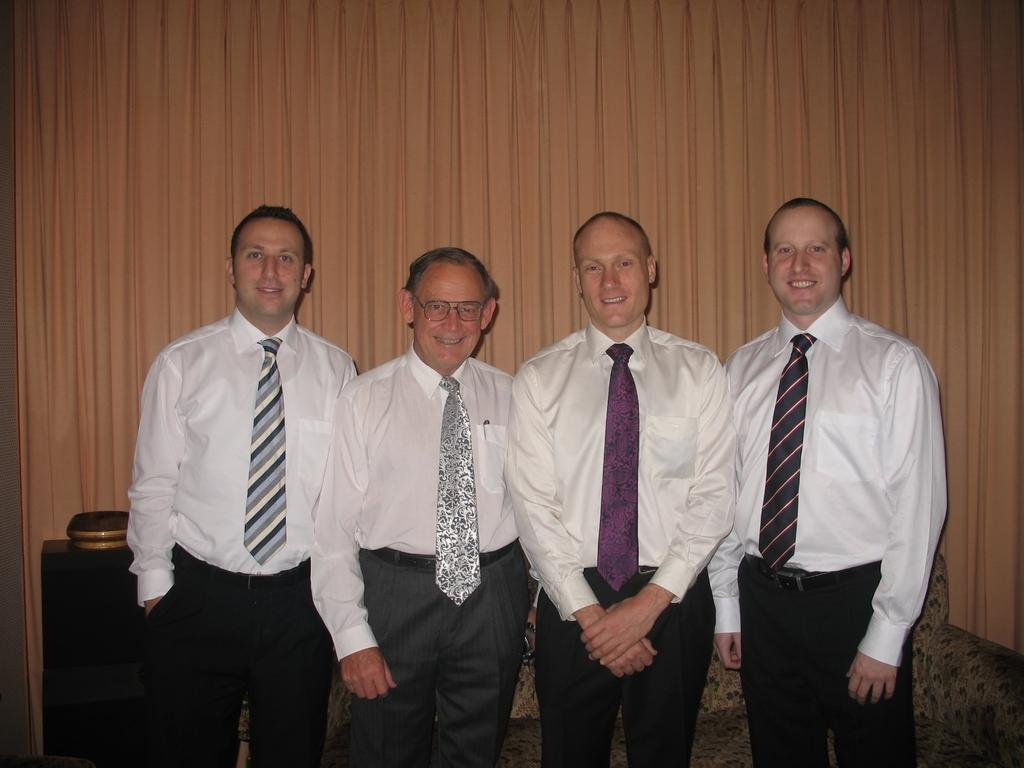How many people are present in the image? There are four people standing in the image. What are the people wearing around their necks? All four people are wearing ties. What can be seen in the background of the image? There is a curtain in the background of the image. What type of furniture is visible at the bottom of the image? A sofa is visible at the bottom of the image. What object is also present at the bottom of the image? There is a stand at the bottom of the image. What type of light is hanging above the people in the image? There is no light visible above the people in the image. 